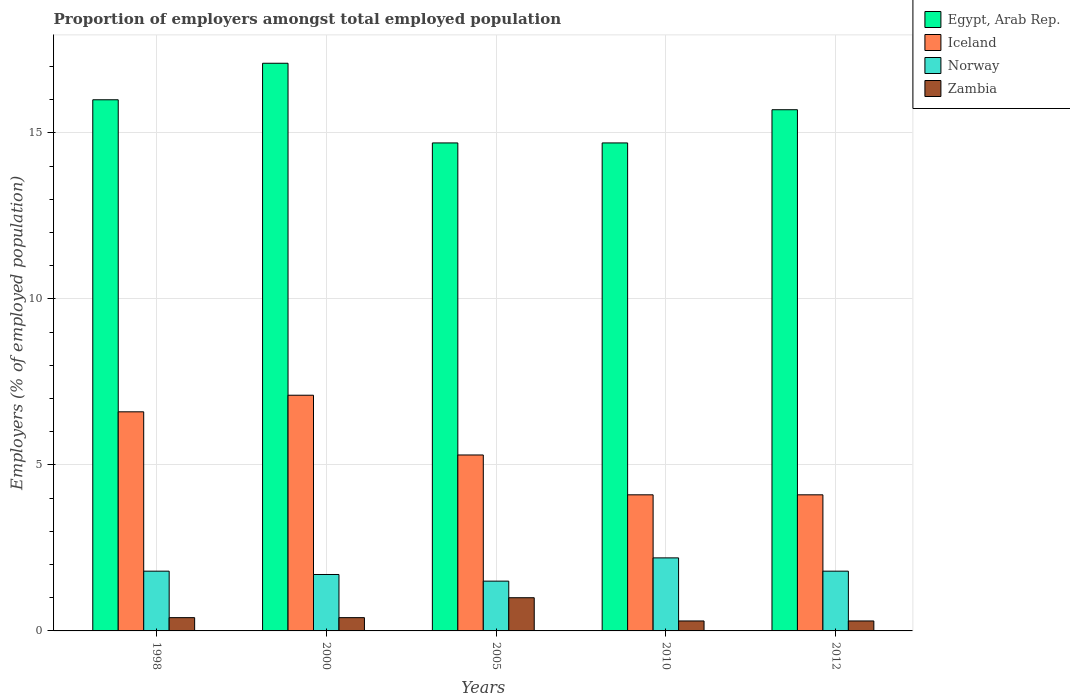How many bars are there on the 1st tick from the left?
Ensure brevity in your answer.  4. How many bars are there on the 2nd tick from the right?
Keep it short and to the point. 4. In how many cases, is the number of bars for a given year not equal to the number of legend labels?
Your answer should be compact. 0. What is the proportion of employers in Egypt, Arab Rep. in 1998?
Provide a short and direct response. 16. Across all years, what is the maximum proportion of employers in Norway?
Your response must be concise. 2.2. Across all years, what is the minimum proportion of employers in Zambia?
Offer a terse response. 0.3. In which year was the proportion of employers in Iceland minimum?
Make the answer very short. 2010. What is the total proportion of employers in Egypt, Arab Rep. in the graph?
Your response must be concise. 78.2. What is the difference between the proportion of employers in Egypt, Arab Rep. in 1998 and that in 2005?
Keep it short and to the point. 1.3. What is the difference between the proportion of employers in Egypt, Arab Rep. in 2005 and the proportion of employers in Norway in 1998?
Your answer should be compact. 12.9. What is the average proportion of employers in Zambia per year?
Provide a succinct answer. 0.48. In the year 2010, what is the difference between the proportion of employers in Egypt, Arab Rep. and proportion of employers in Zambia?
Ensure brevity in your answer.  14.4. In how many years, is the proportion of employers in Norway greater than 3 %?
Your answer should be very brief. 0. What is the ratio of the proportion of employers in Iceland in 1998 to that in 2005?
Provide a short and direct response. 1.25. What is the difference between the highest and the second highest proportion of employers in Egypt, Arab Rep.?
Your answer should be very brief. 1.1. What is the difference between the highest and the lowest proportion of employers in Egypt, Arab Rep.?
Your answer should be compact. 2.4. Is the sum of the proportion of employers in Zambia in 2010 and 2012 greater than the maximum proportion of employers in Iceland across all years?
Provide a succinct answer. No. What does the 2nd bar from the left in 1998 represents?
Your response must be concise. Iceland. What does the 3rd bar from the right in 2012 represents?
Your answer should be very brief. Iceland. Is it the case that in every year, the sum of the proportion of employers in Egypt, Arab Rep. and proportion of employers in Norway is greater than the proportion of employers in Iceland?
Your answer should be compact. Yes. Are all the bars in the graph horizontal?
Offer a terse response. No. How many years are there in the graph?
Offer a very short reply. 5. Are the values on the major ticks of Y-axis written in scientific E-notation?
Offer a terse response. No. Does the graph contain grids?
Your answer should be compact. Yes. Where does the legend appear in the graph?
Offer a very short reply. Top right. What is the title of the graph?
Make the answer very short. Proportion of employers amongst total employed population. Does "Greenland" appear as one of the legend labels in the graph?
Keep it short and to the point. No. What is the label or title of the Y-axis?
Offer a very short reply. Employers (% of employed population). What is the Employers (% of employed population) of Iceland in 1998?
Provide a succinct answer. 6.6. What is the Employers (% of employed population) in Norway in 1998?
Provide a succinct answer. 1.8. What is the Employers (% of employed population) in Zambia in 1998?
Your answer should be compact. 0.4. What is the Employers (% of employed population) of Egypt, Arab Rep. in 2000?
Offer a terse response. 17.1. What is the Employers (% of employed population) of Iceland in 2000?
Provide a succinct answer. 7.1. What is the Employers (% of employed population) of Norway in 2000?
Ensure brevity in your answer.  1.7. What is the Employers (% of employed population) of Zambia in 2000?
Your response must be concise. 0.4. What is the Employers (% of employed population) in Egypt, Arab Rep. in 2005?
Your answer should be very brief. 14.7. What is the Employers (% of employed population) in Iceland in 2005?
Make the answer very short. 5.3. What is the Employers (% of employed population) in Norway in 2005?
Offer a terse response. 1.5. What is the Employers (% of employed population) of Egypt, Arab Rep. in 2010?
Keep it short and to the point. 14.7. What is the Employers (% of employed population) in Iceland in 2010?
Offer a very short reply. 4.1. What is the Employers (% of employed population) in Norway in 2010?
Your answer should be very brief. 2.2. What is the Employers (% of employed population) in Zambia in 2010?
Make the answer very short. 0.3. What is the Employers (% of employed population) of Egypt, Arab Rep. in 2012?
Your answer should be compact. 15.7. What is the Employers (% of employed population) of Iceland in 2012?
Provide a succinct answer. 4.1. What is the Employers (% of employed population) in Norway in 2012?
Your answer should be compact. 1.8. What is the Employers (% of employed population) in Zambia in 2012?
Give a very brief answer. 0.3. Across all years, what is the maximum Employers (% of employed population) of Egypt, Arab Rep.?
Your answer should be very brief. 17.1. Across all years, what is the maximum Employers (% of employed population) in Iceland?
Make the answer very short. 7.1. Across all years, what is the maximum Employers (% of employed population) of Norway?
Your response must be concise. 2.2. Across all years, what is the minimum Employers (% of employed population) of Egypt, Arab Rep.?
Provide a succinct answer. 14.7. Across all years, what is the minimum Employers (% of employed population) in Iceland?
Give a very brief answer. 4.1. Across all years, what is the minimum Employers (% of employed population) of Zambia?
Give a very brief answer. 0.3. What is the total Employers (% of employed population) in Egypt, Arab Rep. in the graph?
Offer a very short reply. 78.2. What is the total Employers (% of employed population) in Iceland in the graph?
Your answer should be compact. 27.2. What is the difference between the Employers (% of employed population) of Egypt, Arab Rep. in 1998 and that in 2000?
Give a very brief answer. -1.1. What is the difference between the Employers (% of employed population) in Norway in 1998 and that in 2000?
Keep it short and to the point. 0.1. What is the difference between the Employers (% of employed population) in Zambia in 1998 and that in 2000?
Keep it short and to the point. 0. What is the difference between the Employers (% of employed population) of Egypt, Arab Rep. in 1998 and that in 2005?
Make the answer very short. 1.3. What is the difference between the Employers (% of employed population) in Iceland in 1998 and that in 2005?
Provide a short and direct response. 1.3. What is the difference between the Employers (% of employed population) of Norway in 1998 and that in 2005?
Make the answer very short. 0.3. What is the difference between the Employers (% of employed population) of Zambia in 1998 and that in 2005?
Give a very brief answer. -0.6. What is the difference between the Employers (% of employed population) of Egypt, Arab Rep. in 1998 and that in 2010?
Keep it short and to the point. 1.3. What is the difference between the Employers (% of employed population) in Iceland in 1998 and that in 2010?
Your response must be concise. 2.5. What is the difference between the Employers (% of employed population) of Norway in 1998 and that in 2010?
Keep it short and to the point. -0.4. What is the difference between the Employers (% of employed population) of Egypt, Arab Rep. in 1998 and that in 2012?
Make the answer very short. 0.3. What is the difference between the Employers (% of employed population) in Iceland in 1998 and that in 2012?
Your answer should be compact. 2.5. What is the difference between the Employers (% of employed population) of Egypt, Arab Rep. in 2000 and that in 2005?
Give a very brief answer. 2.4. What is the difference between the Employers (% of employed population) of Norway in 2000 and that in 2005?
Provide a succinct answer. 0.2. What is the difference between the Employers (% of employed population) of Zambia in 2000 and that in 2005?
Your answer should be compact. -0.6. What is the difference between the Employers (% of employed population) in Iceland in 2000 and that in 2010?
Keep it short and to the point. 3. What is the difference between the Employers (% of employed population) in Zambia in 2000 and that in 2010?
Provide a succinct answer. 0.1. What is the difference between the Employers (% of employed population) in Egypt, Arab Rep. in 2000 and that in 2012?
Your response must be concise. 1.4. What is the difference between the Employers (% of employed population) in Iceland in 2000 and that in 2012?
Offer a terse response. 3. What is the difference between the Employers (% of employed population) in Iceland in 2005 and that in 2010?
Your answer should be very brief. 1.2. What is the difference between the Employers (% of employed population) of Norway in 2005 and that in 2010?
Offer a very short reply. -0.7. What is the difference between the Employers (% of employed population) in Egypt, Arab Rep. in 2010 and that in 2012?
Provide a short and direct response. -1. What is the difference between the Employers (% of employed population) in Norway in 2010 and that in 2012?
Ensure brevity in your answer.  0.4. What is the difference between the Employers (% of employed population) in Egypt, Arab Rep. in 1998 and the Employers (% of employed population) in Iceland in 2000?
Give a very brief answer. 8.9. What is the difference between the Employers (% of employed population) in Egypt, Arab Rep. in 1998 and the Employers (% of employed population) in Zambia in 2000?
Your answer should be compact. 15.6. What is the difference between the Employers (% of employed population) in Iceland in 1998 and the Employers (% of employed population) in Norway in 2000?
Keep it short and to the point. 4.9. What is the difference between the Employers (% of employed population) of Iceland in 1998 and the Employers (% of employed population) of Zambia in 2000?
Ensure brevity in your answer.  6.2. What is the difference between the Employers (% of employed population) of Norway in 1998 and the Employers (% of employed population) of Zambia in 2000?
Provide a short and direct response. 1.4. What is the difference between the Employers (% of employed population) of Egypt, Arab Rep. in 1998 and the Employers (% of employed population) of Norway in 2005?
Provide a succinct answer. 14.5. What is the difference between the Employers (% of employed population) in Egypt, Arab Rep. in 1998 and the Employers (% of employed population) in Zambia in 2005?
Your answer should be very brief. 15. What is the difference between the Employers (% of employed population) in Norway in 1998 and the Employers (% of employed population) in Zambia in 2005?
Keep it short and to the point. 0.8. What is the difference between the Employers (% of employed population) in Egypt, Arab Rep. in 1998 and the Employers (% of employed population) in Norway in 2010?
Offer a very short reply. 13.8. What is the difference between the Employers (% of employed population) in Egypt, Arab Rep. in 1998 and the Employers (% of employed population) in Zambia in 2010?
Your answer should be compact. 15.7. What is the difference between the Employers (% of employed population) of Iceland in 1998 and the Employers (% of employed population) of Norway in 2010?
Make the answer very short. 4.4. What is the difference between the Employers (% of employed population) in Iceland in 1998 and the Employers (% of employed population) in Zambia in 2010?
Offer a terse response. 6.3. What is the difference between the Employers (% of employed population) in Norway in 1998 and the Employers (% of employed population) in Zambia in 2010?
Keep it short and to the point. 1.5. What is the difference between the Employers (% of employed population) in Egypt, Arab Rep. in 1998 and the Employers (% of employed population) in Iceland in 2012?
Provide a succinct answer. 11.9. What is the difference between the Employers (% of employed population) in Egypt, Arab Rep. in 1998 and the Employers (% of employed population) in Norway in 2012?
Your answer should be compact. 14.2. What is the difference between the Employers (% of employed population) of Egypt, Arab Rep. in 2000 and the Employers (% of employed population) of Iceland in 2005?
Ensure brevity in your answer.  11.8. What is the difference between the Employers (% of employed population) of Norway in 2000 and the Employers (% of employed population) of Zambia in 2005?
Give a very brief answer. 0.7. What is the difference between the Employers (% of employed population) in Egypt, Arab Rep. in 2000 and the Employers (% of employed population) in Iceland in 2010?
Your answer should be very brief. 13. What is the difference between the Employers (% of employed population) of Egypt, Arab Rep. in 2000 and the Employers (% of employed population) of Norway in 2010?
Your answer should be very brief. 14.9. What is the difference between the Employers (% of employed population) of Iceland in 2000 and the Employers (% of employed population) of Zambia in 2010?
Offer a very short reply. 6.8. What is the difference between the Employers (% of employed population) in Egypt, Arab Rep. in 2000 and the Employers (% of employed population) in Norway in 2012?
Give a very brief answer. 15.3. What is the difference between the Employers (% of employed population) in Egypt, Arab Rep. in 2000 and the Employers (% of employed population) in Zambia in 2012?
Your response must be concise. 16.8. What is the difference between the Employers (% of employed population) in Iceland in 2000 and the Employers (% of employed population) in Norway in 2012?
Your response must be concise. 5.3. What is the difference between the Employers (% of employed population) of Norway in 2000 and the Employers (% of employed population) of Zambia in 2012?
Your answer should be very brief. 1.4. What is the difference between the Employers (% of employed population) in Egypt, Arab Rep. in 2005 and the Employers (% of employed population) in Zambia in 2010?
Your answer should be very brief. 14.4. What is the difference between the Employers (% of employed population) of Iceland in 2005 and the Employers (% of employed population) of Norway in 2010?
Ensure brevity in your answer.  3.1. What is the difference between the Employers (% of employed population) of Norway in 2005 and the Employers (% of employed population) of Zambia in 2010?
Offer a terse response. 1.2. What is the difference between the Employers (% of employed population) of Egypt, Arab Rep. in 2005 and the Employers (% of employed population) of Iceland in 2012?
Ensure brevity in your answer.  10.6. What is the difference between the Employers (% of employed population) of Egypt, Arab Rep. in 2005 and the Employers (% of employed population) of Norway in 2012?
Ensure brevity in your answer.  12.9. What is the difference between the Employers (% of employed population) in Egypt, Arab Rep. in 2005 and the Employers (% of employed population) in Zambia in 2012?
Your response must be concise. 14.4. What is the difference between the Employers (% of employed population) of Iceland in 2005 and the Employers (% of employed population) of Zambia in 2012?
Provide a short and direct response. 5. What is the difference between the Employers (% of employed population) in Norway in 2005 and the Employers (% of employed population) in Zambia in 2012?
Offer a very short reply. 1.2. What is the difference between the Employers (% of employed population) of Egypt, Arab Rep. in 2010 and the Employers (% of employed population) of Iceland in 2012?
Provide a short and direct response. 10.6. What is the difference between the Employers (% of employed population) in Egypt, Arab Rep. in 2010 and the Employers (% of employed population) in Zambia in 2012?
Give a very brief answer. 14.4. What is the difference between the Employers (% of employed population) in Iceland in 2010 and the Employers (% of employed population) in Norway in 2012?
Your answer should be compact. 2.3. What is the difference between the Employers (% of employed population) of Iceland in 2010 and the Employers (% of employed population) of Zambia in 2012?
Your answer should be very brief. 3.8. What is the difference between the Employers (% of employed population) of Norway in 2010 and the Employers (% of employed population) of Zambia in 2012?
Your answer should be very brief. 1.9. What is the average Employers (% of employed population) of Egypt, Arab Rep. per year?
Your answer should be very brief. 15.64. What is the average Employers (% of employed population) of Iceland per year?
Your response must be concise. 5.44. What is the average Employers (% of employed population) in Zambia per year?
Provide a succinct answer. 0.48. In the year 1998, what is the difference between the Employers (% of employed population) in Egypt, Arab Rep. and Employers (% of employed population) in Norway?
Ensure brevity in your answer.  14.2. In the year 1998, what is the difference between the Employers (% of employed population) of Iceland and Employers (% of employed population) of Norway?
Your answer should be compact. 4.8. In the year 1998, what is the difference between the Employers (% of employed population) in Iceland and Employers (% of employed population) in Zambia?
Your answer should be compact. 6.2. In the year 1998, what is the difference between the Employers (% of employed population) in Norway and Employers (% of employed population) in Zambia?
Give a very brief answer. 1.4. In the year 2000, what is the difference between the Employers (% of employed population) of Egypt, Arab Rep. and Employers (% of employed population) of Iceland?
Your response must be concise. 10. In the year 2000, what is the difference between the Employers (% of employed population) in Egypt, Arab Rep. and Employers (% of employed population) in Zambia?
Your response must be concise. 16.7. In the year 2000, what is the difference between the Employers (% of employed population) in Iceland and Employers (% of employed population) in Norway?
Your answer should be compact. 5.4. In the year 2005, what is the difference between the Employers (% of employed population) of Egypt, Arab Rep. and Employers (% of employed population) of Iceland?
Provide a short and direct response. 9.4. In the year 2005, what is the difference between the Employers (% of employed population) in Egypt, Arab Rep. and Employers (% of employed population) in Zambia?
Keep it short and to the point. 13.7. In the year 2010, what is the difference between the Employers (% of employed population) of Egypt, Arab Rep. and Employers (% of employed population) of Iceland?
Your response must be concise. 10.6. In the year 2010, what is the difference between the Employers (% of employed population) in Iceland and Employers (% of employed population) in Norway?
Your response must be concise. 1.9. In the year 2012, what is the difference between the Employers (% of employed population) in Egypt, Arab Rep. and Employers (% of employed population) in Norway?
Offer a terse response. 13.9. In the year 2012, what is the difference between the Employers (% of employed population) of Iceland and Employers (% of employed population) of Norway?
Your response must be concise. 2.3. In the year 2012, what is the difference between the Employers (% of employed population) in Iceland and Employers (% of employed population) in Zambia?
Offer a terse response. 3.8. What is the ratio of the Employers (% of employed population) in Egypt, Arab Rep. in 1998 to that in 2000?
Your answer should be compact. 0.94. What is the ratio of the Employers (% of employed population) in Iceland in 1998 to that in 2000?
Your answer should be compact. 0.93. What is the ratio of the Employers (% of employed population) in Norway in 1998 to that in 2000?
Your answer should be very brief. 1.06. What is the ratio of the Employers (% of employed population) in Egypt, Arab Rep. in 1998 to that in 2005?
Give a very brief answer. 1.09. What is the ratio of the Employers (% of employed population) of Iceland in 1998 to that in 2005?
Give a very brief answer. 1.25. What is the ratio of the Employers (% of employed population) in Norway in 1998 to that in 2005?
Your answer should be compact. 1.2. What is the ratio of the Employers (% of employed population) in Zambia in 1998 to that in 2005?
Offer a very short reply. 0.4. What is the ratio of the Employers (% of employed population) of Egypt, Arab Rep. in 1998 to that in 2010?
Your answer should be very brief. 1.09. What is the ratio of the Employers (% of employed population) of Iceland in 1998 to that in 2010?
Offer a terse response. 1.61. What is the ratio of the Employers (% of employed population) of Norway in 1998 to that in 2010?
Offer a terse response. 0.82. What is the ratio of the Employers (% of employed population) of Zambia in 1998 to that in 2010?
Your answer should be compact. 1.33. What is the ratio of the Employers (% of employed population) of Egypt, Arab Rep. in 1998 to that in 2012?
Provide a succinct answer. 1.02. What is the ratio of the Employers (% of employed population) in Iceland in 1998 to that in 2012?
Keep it short and to the point. 1.61. What is the ratio of the Employers (% of employed population) in Norway in 1998 to that in 2012?
Make the answer very short. 1. What is the ratio of the Employers (% of employed population) of Zambia in 1998 to that in 2012?
Your response must be concise. 1.33. What is the ratio of the Employers (% of employed population) in Egypt, Arab Rep. in 2000 to that in 2005?
Your answer should be compact. 1.16. What is the ratio of the Employers (% of employed population) of Iceland in 2000 to that in 2005?
Offer a terse response. 1.34. What is the ratio of the Employers (% of employed population) of Norway in 2000 to that in 2005?
Offer a terse response. 1.13. What is the ratio of the Employers (% of employed population) of Zambia in 2000 to that in 2005?
Your answer should be very brief. 0.4. What is the ratio of the Employers (% of employed population) of Egypt, Arab Rep. in 2000 to that in 2010?
Your answer should be compact. 1.16. What is the ratio of the Employers (% of employed population) in Iceland in 2000 to that in 2010?
Your response must be concise. 1.73. What is the ratio of the Employers (% of employed population) in Norway in 2000 to that in 2010?
Give a very brief answer. 0.77. What is the ratio of the Employers (% of employed population) in Zambia in 2000 to that in 2010?
Offer a very short reply. 1.33. What is the ratio of the Employers (% of employed population) in Egypt, Arab Rep. in 2000 to that in 2012?
Your answer should be very brief. 1.09. What is the ratio of the Employers (% of employed population) in Iceland in 2000 to that in 2012?
Provide a short and direct response. 1.73. What is the ratio of the Employers (% of employed population) in Egypt, Arab Rep. in 2005 to that in 2010?
Provide a short and direct response. 1. What is the ratio of the Employers (% of employed population) in Iceland in 2005 to that in 2010?
Your response must be concise. 1.29. What is the ratio of the Employers (% of employed population) in Norway in 2005 to that in 2010?
Provide a short and direct response. 0.68. What is the ratio of the Employers (% of employed population) in Egypt, Arab Rep. in 2005 to that in 2012?
Offer a very short reply. 0.94. What is the ratio of the Employers (% of employed population) in Iceland in 2005 to that in 2012?
Offer a very short reply. 1.29. What is the ratio of the Employers (% of employed population) in Norway in 2005 to that in 2012?
Keep it short and to the point. 0.83. What is the ratio of the Employers (% of employed population) of Egypt, Arab Rep. in 2010 to that in 2012?
Your answer should be very brief. 0.94. What is the ratio of the Employers (% of employed population) of Iceland in 2010 to that in 2012?
Your answer should be very brief. 1. What is the ratio of the Employers (% of employed population) in Norway in 2010 to that in 2012?
Your response must be concise. 1.22. What is the ratio of the Employers (% of employed population) of Zambia in 2010 to that in 2012?
Provide a short and direct response. 1. What is the difference between the highest and the second highest Employers (% of employed population) of Egypt, Arab Rep.?
Offer a very short reply. 1.1. What is the difference between the highest and the second highest Employers (% of employed population) of Iceland?
Your answer should be compact. 0.5. What is the difference between the highest and the lowest Employers (% of employed population) of Egypt, Arab Rep.?
Offer a very short reply. 2.4. 